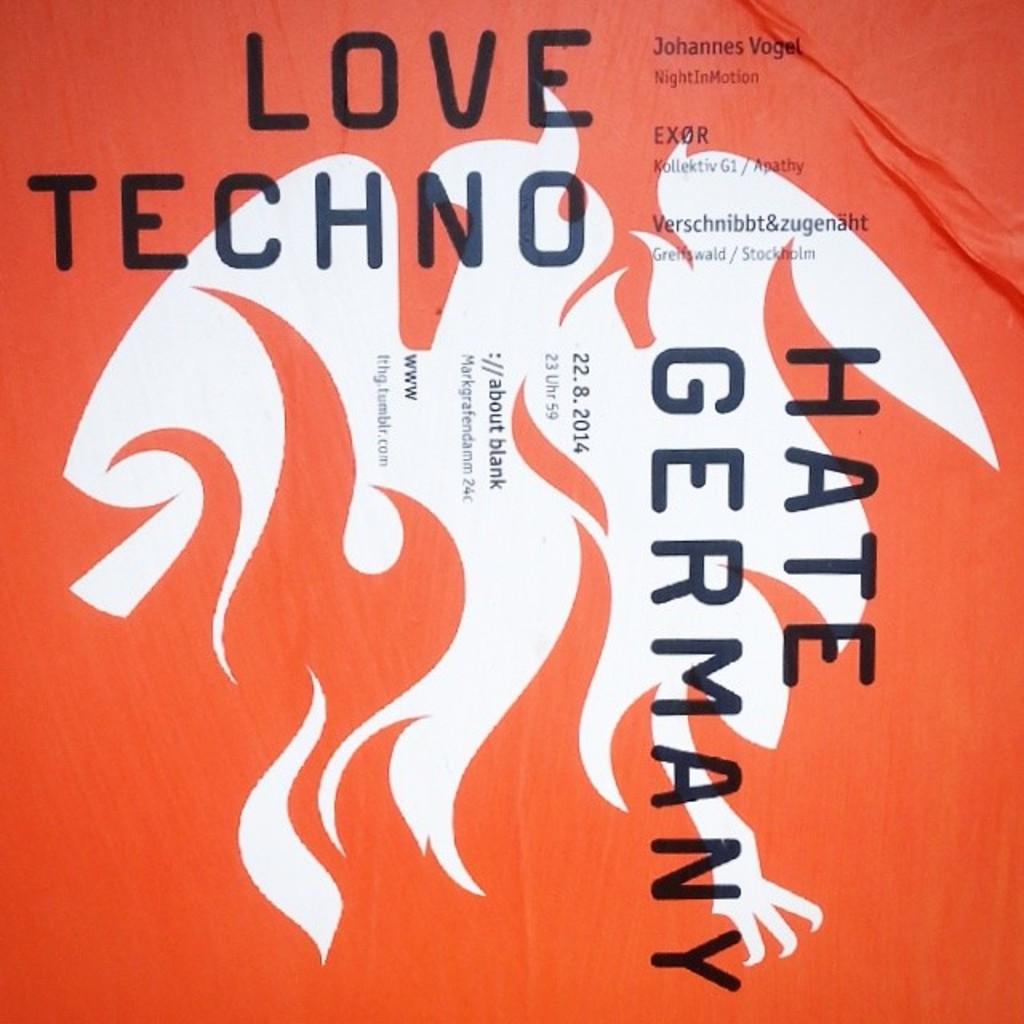What should you love?
Provide a succinct answer. Techno. What do they love and hate?
Make the answer very short. Love techno hate germany. 